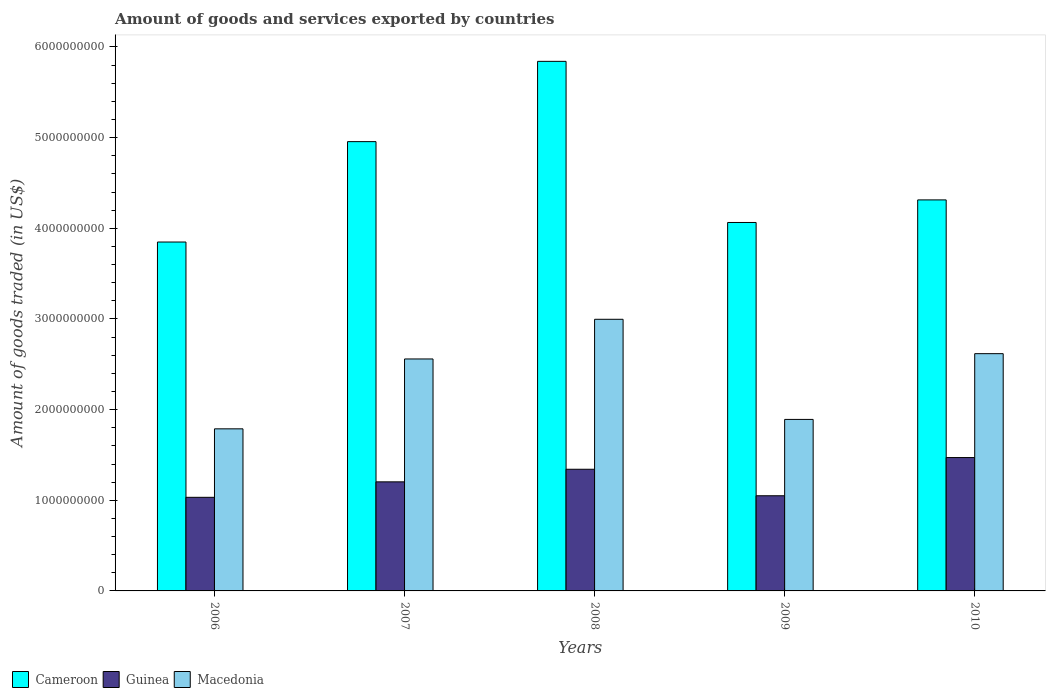How many different coloured bars are there?
Keep it short and to the point. 3. Are the number of bars per tick equal to the number of legend labels?
Offer a terse response. Yes. Are the number of bars on each tick of the X-axis equal?
Ensure brevity in your answer.  Yes. What is the total amount of goods and services exported in Guinea in 2007?
Give a very brief answer. 1.20e+09. Across all years, what is the maximum total amount of goods and services exported in Guinea?
Ensure brevity in your answer.  1.47e+09. Across all years, what is the minimum total amount of goods and services exported in Macedonia?
Give a very brief answer. 1.79e+09. In which year was the total amount of goods and services exported in Macedonia minimum?
Give a very brief answer. 2006. What is the total total amount of goods and services exported in Cameroon in the graph?
Your answer should be very brief. 2.30e+1. What is the difference between the total amount of goods and services exported in Cameroon in 2006 and that in 2010?
Your answer should be very brief. -4.65e+08. What is the difference between the total amount of goods and services exported in Guinea in 2010 and the total amount of goods and services exported in Macedonia in 2009?
Offer a very short reply. -4.21e+08. What is the average total amount of goods and services exported in Guinea per year?
Your answer should be compact. 1.22e+09. In the year 2007, what is the difference between the total amount of goods and services exported in Guinea and total amount of goods and services exported in Cameroon?
Ensure brevity in your answer.  -3.75e+09. What is the ratio of the total amount of goods and services exported in Cameroon in 2007 to that in 2010?
Offer a terse response. 1.15. Is the total amount of goods and services exported in Guinea in 2009 less than that in 2010?
Make the answer very short. Yes. Is the difference between the total amount of goods and services exported in Guinea in 2006 and 2007 greater than the difference between the total amount of goods and services exported in Cameroon in 2006 and 2007?
Make the answer very short. Yes. What is the difference between the highest and the second highest total amount of goods and services exported in Macedonia?
Your answer should be compact. 3.79e+08. What is the difference between the highest and the lowest total amount of goods and services exported in Macedonia?
Provide a succinct answer. 1.21e+09. In how many years, is the total amount of goods and services exported in Cameroon greater than the average total amount of goods and services exported in Cameroon taken over all years?
Ensure brevity in your answer.  2. Is the sum of the total amount of goods and services exported in Guinea in 2006 and 2008 greater than the maximum total amount of goods and services exported in Macedonia across all years?
Provide a succinct answer. No. What does the 3rd bar from the left in 2006 represents?
Keep it short and to the point. Macedonia. What does the 1st bar from the right in 2008 represents?
Give a very brief answer. Macedonia. Is it the case that in every year, the sum of the total amount of goods and services exported in Guinea and total amount of goods and services exported in Macedonia is greater than the total amount of goods and services exported in Cameroon?
Your response must be concise. No. How many years are there in the graph?
Offer a terse response. 5. Are the values on the major ticks of Y-axis written in scientific E-notation?
Keep it short and to the point. No. How many legend labels are there?
Provide a short and direct response. 3. How are the legend labels stacked?
Your answer should be very brief. Horizontal. What is the title of the graph?
Make the answer very short. Amount of goods and services exported by countries. Does "Latvia" appear as one of the legend labels in the graph?
Offer a terse response. No. What is the label or title of the X-axis?
Provide a succinct answer. Years. What is the label or title of the Y-axis?
Your answer should be compact. Amount of goods traded (in US$). What is the Amount of goods traded (in US$) in Cameroon in 2006?
Provide a succinct answer. 3.85e+09. What is the Amount of goods traded (in US$) in Guinea in 2006?
Your answer should be very brief. 1.03e+09. What is the Amount of goods traded (in US$) of Macedonia in 2006?
Ensure brevity in your answer.  1.79e+09. What is the Amount of goods traded (in US$) in Cameroon in 2007?
Keep it short and to the point. 4.96e+09. What is the Amount of goods traded (in US$) in Guinea in 2007?
Keep it short and to the point. 1.20e+09. What is the Amount of goods traded (in US$) in Macedonia in 2007?
Provide a short and direct response. 2.56e+09. What is the Amount of goods traded (in US$) in Cameroon in 2008?
Your answer should be compact. 5.84e+09. What is the Amount of goods traded (in US$) in Guinea in 2008?
Offer a terse response. 1.34e+09. What is the Amount of goods traded (in US$) in Macedonia in 2008?
Provide a succinct answer. 3.00e+09. What is the Amount of goods traded (in US$) in Cameroon in 2009?
Make the answer very short. 4.06e+09. What is the Amount of goods traded (in US$) in Guinea in 2009?
Keep it short and to the point. 1.05e+09. What is the Amount of goods traded (in US$) in Macedonia in 2009?
Keep it short and to the point. 1.89e+09. What is the Amount of goods traded (in US$) in Cameroon in 2010?
Your response must be concise. 4.31e+09. What is the Amount of goods traded (in US$) of Guinea in 2010?
Give a very brief answer. 1.47e+09. What is the Amount of goods traded (in US$) in Macedonia in 2010?
Make the answer very short. 2.62e+09. Across all years, what is the maximum Amount of goods traded (in US$) in Cameroon?
Keep it short and to the point. 5.84e+09. Across all years, what is the maximum Amount of goods traded (in US$) in Guinea?
Keep it short and to the point. 1.47e+09. Across all years, what is the maximum Amount of goods traded (in US$) in Macedonia?
Give a very brief answer. 3.00e+09. Across all years, what is the minimum Amount of goods traded (in US$) of Cameroon?
Give a very brief answer. 3.85e+09. Across all years, what is the minimum Amount of goods traded (in US$) of Guinea?
Ensure brevity in your answer.  1.03e+09. Across all years, what is the minimum Amount of goods traded (in US$) in Macedonia?
Your response must be concise. 1.79e+09. What is the total Amount of goods traded (in US$) in Cameroon in the graph?
Your response must be concise. 2.30e+1. What is the total Amount of goods traded (in US$) in Guinea in the graph?
Your answer should be very brief. 6.10e+09. What is the total Amount of goods traded (in US$) in Macedonia in the graph?
Give a very brief answer. 1.19e+1. What is the difference between the Amount of goods traded (in US$) of Cameroon in 2006 and that in 2007?
Your answer should be very brief. -1.11e+09. What is the difference between the Amount of goods traded (in US$) in Guinea in 2006 and that in 2007?
Provide a short and direct response. -1.71e+08. What is the difference between the Amount of goods traded (in US$) of Macedonia in 2006 and that in 2007?
Your answer should be compact. -7.71e+08. What is the difference between the Amount of goods traded (in US$) in Cameroon in 2006 and that in 2008?
Offer a terse response. -1.99e+09. What is the difference between the Amount of goods traded (in US$) in Guinea in 2006 and that in 2008?
Keep it short and to the point. -3.09e+08. What is the difference between the Amount of goods traded (in US$) of Macedonia in 2006 and that in 2008?
Keep it short and to the point. -1.21e+09. What is the difference between the Amount of goods traded (in US$) in Cameroon in 2006 and that in 2009?
Ensure brevity in your answer.  -2.16e+08. What is the difference between the Amount of goods traded (in US$) in Guinea in 2006 and that in 2009?
Your answer should be very brief. -1.71e+07. What is the difference between the Amount of goods traded (in US$) in Macedonia in 2006 and that in 2009?
Provide a succinct answer. -1.04e+08. What is the difference between the Amount of goods traded (in US$) in Cameroon in 2006 and that in 2010?
Give a very brief answer. -4.65e+08. What is the difference between the Amount of goods traded (in US$) in Guinea in 2006 and that in 2010?
Provide a succinct answer. -4.39e+08. What is the difference between the Amount of goods traded (in US$) of Macedonia in 2006 and that in 2010?
Your answer should be very brief. -8.29e+08. What is the difference between the Amount of goods traded (in US$) of Cameroon in 2007 and that in 2008?
Your answer should be very brief. -8.86e+08. What is the difference between the Amount of goods traded (in US$) of Guinea in 2007 and that in 2008?
Offer a terse response. -1.39e+08. What is the difference between the Amount of goods traded (in US$) in Macedonia in 2007 and that in 2008?
Keep it short and to the point. -4.38e+08. What is the difference between the Amount of goods traded (in US$) in Cameroon in 2007 and that in 2009?
Keep it short and to the point. 8.92e+08. What is the difference between the Amount of goods traded (in US$) of Guinea in 2007 and that in 2009?
Provide a succinct answer. 1.53e+08. What is the difference between the Amount of goods traded (in US$) of Macedonia in 2007 and that in 2009?
Provide a succinct answer. 6.67e+08. What is the difference between the Amount of goods traded (in US$) in Cameroon in 2007 and that in 2010?
Your answer should be compact. 6.43e+08. What is the difference between the Amount of goods traded (in US$) of Guinea in 2007 and that in 2010?
Your answer should be very brief. -2.68e+08. What is the difference between the Amount of goods traded (in US$) in Macedonia in 2007 and that in 2010?
Your answer should be very brief. -5.85e+07. What is the difference between the Amount of goods traded (in US$) in Cameroon in 2008 and that in 2009?
Give a very brief answer. 1.78e+09. What is the difference between the Amount of goods traded (in US$) in Guinea in 2008 and that in 2009?
Give a very brief answer. 2.92e+08. What is the difference between the Amount of goods traded (in US$) of Macedonia in 2008 and that in 2009?
Your response must be concise. 1.10e+09. What is the difference between the Amount of goods traded (in US$) in Cameroon in 2008 and that in 2010?
Make the answer very short. 1.53e+09. What is the difference between the Amount of goods traded (in US$) of Guinea in 2008 and that in 2010?
Keep it short and to the point. -1.29e+08. What is the difference between the Amount of goods traded (in US$) of Macedonia in 2008 and that in 2010?
Give a very brief answer. 3.79e+08. What is the difference between the Amount of goods traded (in US$) in Cameroon in 2009 and that in 2010?
Give a very brief answer. -2.49e+08. What is the difference between the Amount of goods traded (in US$) of Guinea in 2009 and that in 2010?
Make the answer very short. -4.21e+08. What is the difference between the Amount of goods traded (in US$) of Macedonia in 2009 and that in 2010?
Your response must be concise. -7.25e+08. What is the difference between the Amount of goods traded (in US$) in Cameroon in 2006 and the Amount of goods traded (in US$) in Guinea in 2007?
Your answer should be very brief. 2.65e+09. What is the difference between the Amount of goods traded (in US$) in Cameroon in 2006 and the Amount of goods traded (in US$) in Macedonia in 2007?
Your answer should be very brief. 1.29e+09. What is the difference between the Amount of goods traded (in US$) of Guinea in 2006 and the Amount of goods traded (in US$) of Macedonia in 2007?
Make the answer very short. -1.53e+09. What is the difference between the Amount of goods traded (in US$) in Cameroon in 2006 and the Amount of goods traded (in US$) in Guinea in 2008?
Ensure brevity in your answer.  2.51e+09. What is the difference between the Amount of goods traded (in US$) in Cameroon in 2006 and the Amount of goods traded (in US$) in Macedonia in 2008?
Your answer should be very brief. 8.52e+08. What is the difference between the Amount of goods traded (in US$) of Guinea in 2006 and the Amount of goods traded (in US$) of Macedonia in 2008?
Ensure brevity in your answer.  -1.96e+09. What is the difference between the Amount of goods traded (in US$) in Cameroon in 2006 and the Amount of goods traded (in US$) in Guinea in 2009?
Keep it short and to the point. 2.80e+09. What is the difference between the Amount of goods traded (in US$) of Cameroon in 2006 and the Amount of goods traded (in US$) of Macedonia in 2009?
Your answer should be very brief. 1.96e+09. What is the difference between the Amount of goods traded (in US$) of Guinea in 2006 and the Amount of goods traded (in US$) of Macedonia in 2009?
Your answer should be very brief. -8.59e+08. What is the difference between the Amount of goods traded (in US$) of Cameroon in 2006 and the Amount of goods traded (in US$) of Guinea in 2010?
Your answer should be very brief. 2.38e+09. What is the difference between the Amount of goods traded (in US$) of Cameroon in 2006 and the Amount of goods traded (in US$) of Macedonia in 2010?
Your answer should be very brief. 1.23e+09. What is the difference between the Amount of goods traded (in US$) in Guinea in 2006 and the Amount of goods traded (in US$) in Macedonia in 2010?
Your answer should be very brief. -1.58e+09. What is the difference between the Amount of goods traded (in US$) in Cameroon in 2007 and the Amount of goods traded (in US$) in Guinea in 2008?
Your answer should be very brief. 3.61e+09. What is the difference between the Amount of goods traded (in US$) in Cameroon in 2007 and the Amount of goods traded (in US$) in Macedonia in 2008?
Your answer should be very brief. 1.96e+09. What is the difference between the Amount of goods traded (in US$) in Guinea in 2007 and the Amount of goods traded (in US$) in Macedonia in 2008?
Your answer should be very brief. -1.79e+09. What is the difference between the Amount of goods traded (in US$) in Cameroon in 2007 and the Amount of goods traded (in US$) in Guinea in 2009?
Provide a short and direct response. 3.91e+09. What is the difference between the Amount of goods traded (in US$) in Cameroon in 2007 and the Amount of goods traded (in US$) in Macedonia in 2009?
Make the answer very short. 3.06e+09. What is the difference between the Amount of goods traded (in US$) in Guinea in 2007 and the Amount of goods traded (in US$) in Macedonia in 2009?
Your response must be concise. -6.89e+08. What is the difference between the Amount of goods traded (in US$) of Cameroon in 2007 and the Amount of goods traded (in US$) of Guinea in 2010?
Your answer should be compact. 3.48e+09. What is the difference between the Amount of goods traded (in US$) of Cameroon in 2007 and the Amount of goods traded (in US$) of Macedonia in 2010?
Ensure brevity in your answer.  2.34e+09. What is the difference between the Amount of goods traded (in US$) of Guinea in 2007 and the Amount of goods traded (in US$) of Macedonia in 2010?
Make the answer very short. -1.41e+09. What is the difference between the Amount of goods traded (in US$) of Cameroon in 2008 and the Amount of goods traded (in US$) of Guinea in 2009?
Offer a terse response. 4.79e+09. What is the difference between the Amount of goods traded (in US$) in Cameroon in 2008 and the Amount of goods traded (in US$) in Macedonia in 2009?
Offer a terse response. 3.95e+09. What is the difference between the Amount of goods traded (in US$) in Guinea in 2008 and the Amount of goods traded (in US$) in Macedonia in 2009?
Offer a terse response. -5.50e+08. What is the difference between the Amount of goods traded (in US$) of Cameroon in 2008 and the Amount of goods traded (in US$) of Guinea in 2010?
Keep it short and to the point. 4.37e+09. What is the difference between the Amount of goods traded (in US$) of Cameroon in 2008 and the Amount of goods traded (in US$) of Macedonia in 2010?
Ensure brevity in your answer.  3.22e+09. What is the difference between the Amount of goods traded (in US$) of Guinea in 2008 and the Amount of goods traded (in US$) of Macedonia in 2010?
Give a very brief answer. -1.28e+09. What is the difference between the Amount of goods traded (in US$) of Cameroon in 2009 and the Amount of goods traded (in US$) of Guinea in 2010?
Your answer should be compact. 2.59e+09. What is the difference between the Amount of goods traded (in US$) in Cameroon in 2009 and the Amount of goods traded (in US$) in Macedonia in 2010?
Your answer should be compact. 1.45e+09. What is the difference between the Amount of goods traded (in US$) in Guinea in 2009 and the Amount of goods traded (in US$) in Macedonia in 2010?
Keep it short and to the point. -1.57e+09. What is the average Amount of goods traded (in US$) in Cameroon per year?
Keep it short and to the point. 4.60e+09. What is the average Amount of goods traded (in US$) of Guinea per year?
Provide a short and direct response. 1.22e+09. What is the average Amount of goods traded (in US$) in Macedonia per year?
Ensure brevity in your answer.  2.37e+09. In the year 2006, what is the difference between the Amount of goods traded (in US$) in Cameroon and Amount of goods traded (in US$) in Guinea?
Your response must be concise. 2.82e+09. In the year 2006, what is the difference between the Amount of goods traded (in US$) of Cameroon and Amount of goods traded (in US$) of Macedonia?
Provide a succinct answer. 2.06e+09. In the year 2006, what is the difference between the Amount of goods traded (in US$) of Guinea and Amount of goods traded (in US$) of Macedonia?
Make the answer very short. -7.55e+08. In the year 2007, what is the difference between the Amount of goods traded (in US$) of Cameroon and Amount of goods traded (in US$) of Guinea?
Your answer should be very brief. 3.75e+09. In the year 2007, what is the difference between the Amount of goods traded (in US$) of Cameroon and Amount of goods traded (in US$) of Macedonia?
Ensure brevity in your answer.  2.40e+09. In the year 2007, what is the difference between the Amount of goods traded (in US$) of Guinea and Amount of goods traded (in US$) of Macedonia?
Your response must be concise. -1.36e+09. In the year 2008, what is the difference between the Amount of goods traded (in US$) of Cameroon and Amount of goods traded (in US$) of Guinea?
Keep it short and to the point. 4.50e+09. In the year 2008, what is the difference between the Amount of goods traded (in US$) in Cameroon and Amount of goods traded (in US$) in Macedonia?
Your answer should be very brief. 2.85e+09. In the year 2008, what is the difference between the Amount of goods traded (in US$) of Guinea and Amount of goods traded (in US$) of Macedonia?
Offer a very short reply. -1.65e+09. In the year 2009, what is the difference between the Amount of goods traded (in US$) in Cameroon and Amount of goods traded (in US$) in Guinea?
Provide a succinct answer. 3.01e+09. In the year 2009, what is the difference between the Amount of goods traded (in US$) of Cameroon and Amount of goods traded (in US$) of Macedonia?
Offer a terse response. 2.17e+09. In the year 2009, what is the difference between the Amount of goods traded (in US$) in Guinea and Amount of goods traded (in US$) in Macedonia?
Your answer should be compact. -8.42e+08. In the year 2010, what is the difference between the Amount of goods traded (in US$) of Cameroon and Amount of goods traded (in US$) of Guinea?
Your response must be concise. 2.84e+09. In the year 2010, what is the difference between the Amount of goods traded (in US$) of Cameroon and Amount of goods traded (in US$) of Macedonia?
Keep it short and to the point. 1.70e+09. In the year 2010, what is the difference between the Amount of goods traded (in US$) in Guinea and Amount of goods traded (in US$) in Macedonia?
Give a very brief answer. -1.15e+09. What is the ratio of the Amount of goods traded (in US$) in Cameroon in 2006 to that in 2007?
Ensure brevity in your answer.  0.78. What is the ratio of the Amount of goods traded (in US$) of Guinea in 2006 to that in 2007?
Keep it short and to the point. 0.86. What is the ratio of the Amount of goods traded (in US$) in Macedonia in 2006 to that in 2007?
Provide a short and direct response. 0.7. What is the ratio of the Amount of goods traded (in US$) in Cameroon in 2006 to that in 2008?
Your answer should be compact. 0.66. What is the ratio of the Amount of goods traded (in US$) in Guinea in 2006 to that in 2008?
Give a very brief answer. 0.77. What is the ratio of the Amount of goods traded (in US$) of Macedonia in 2006 to that in 2008?
Provide a succinct answer. 0.6. What is the ratio of the Amount of goods traded (in US$) of Cameroon in 2006 to that in 2009?
Your answer should be compact. 0.95. What is the ratio of the Amount of goods traded (in US$) of Guinea in 2006 to that in 2009?
Provide a short and direct response. 0.98. What is the ratio of the Amount of goods traded (in US$) in Macedonia in 2006 to that in 2009?
Ensure brevity in your answer.  0.95. What is the ratio of the Amount of goods traded (in US$) in Cameroon in 2006 to that in 2010?
Offer a terse response. 0.89. What is the ratio of the Amount of goods traded (in US$) in Guinea in 2006 to that in 2010?
Your response must be concise. 0.7. What is the ratio of the Amount of goods traded (in US$) in Macedonia in 2006 to that in 2010?
Provide a succinct answer. 0.68. What is the ratio of the Amount of goods traded (in US$) of Cameroon in 2007 to that in 2008?
Provide a succinct answer. 0.85. What is the ratio of the Amount of goods traded (in US$) in Guinea in 2007 to that in 2008?
Give a very brief answer. 0.9. What is the ratio of the Amount of goods traded (in US$) of Macedonia in 2007 to that in 2008?
Your answer should be compact. 0.85. What is the ratio of the Amount of goods traded (in US$) in Cameroon in 2007 to that in 2009?
Make the answer very short. 1.22. What is the ratio of the Amount of goods traded (in US$) in Guinea in 2007 to that in 2009?
Provide a succinct answer. 1.15. What is the ratio of the Amount of goods traded (in US$) in Macedonia in 2007 to that in 2009?
Ensure brevity in your answer.  1.35. What is the ratio of the Amount of goods traded (in US$) in Cameroon in 2007 to that in 2010?
Your answer should be very brief. 1.15. What is the ratio of the Amount of goods traded (in US$) in Guinea in 2007 to that in 2010?
Provide a succinct answer. 0.82. What is the ratio of the Amount of goods traded (in US$) of Macedonia in 2007 to that in 2010?
Your answer should be compact. 0.98. What is the ratio of the Amount of goods traded (in US$) of Cameroon in 2008 to that in 2009?
Your answer should be very brief. 1.44. What is the ratio of the Amount of goods traded (in US$) of Guinea in 2008 to that in 2009?
Ensure brevity in your answer.  1.28. What is the ratio of the Amount of goods traded (in US$) in Macedonia in 2008 to that in 2009?
Your response must be concise. 1.58. What is the ratio of the Amount of goods traded (in US$) of Cameroon in 2008 to that in 2010?
Give a very brief answer. 1.35. What is the ratio of the Amount of goods traded (in US$) of Guinea in 2008 to that in 2010?
Offer a very short reply. 0.91. What is the ratio of the Amount of goods traded (in US$) in Macedonia in 2008 to that in 2010?
Make the answer very short. 1.14. What is the ratio of the Amount of goods traded (in US$) in Cameroon in 2009 to that in 2010?
Give a very brief answer. 0.94. What is the ratio of the Amount of goods traded (in US$) in Guinea in 2009 to that in 2010?
Offer a terse response. 0.71. What is the ratio of the Amount of goods traded (in US$) in Macedonia in 2009 to that in 2010?
Your response must be concise. 0.72. What is the difference between the highest and the second highest Amount of goods traded (in US$) of Cameroon?
Offer a terse response. 8.86e+08. What is the difference between the highest and the second highest Amount of goods traded (in US$) in Guinea?
Make the answer very short. 1.29e+08. What is the difference between the highest and the second highest Amount of goods traded (in US$) of Macedonia?
Offer a very short reply. 3.79e+08. What is the difference between the highest and the lowest Amount of goods traded (in US$) of Cameroon?
Provide a short and direct response. 1.99e+09. What is the difference between the highest and the lowest Amount of goods traded (in US$) of Guinea?
Your answer should be compact. 4.39e+08. What is the difference between the highest and the lowest Amount of goods traded (in US$) in Macedonia?
Your answer should be very brief. 1.21e+09. 